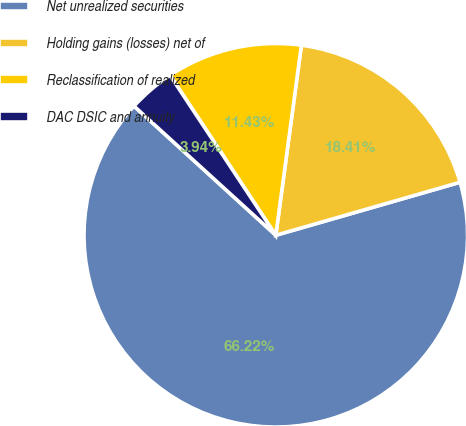<chart> <loc_0><loc_0><loc_500><loc_500><pie_chart><fcel>Net unrealized securities<fcel>Holding gains (losses) net of<fcel>Reclassification of realized<fcel>DAC DSIC and annuity<nl><fcel>66.22%<fcel>18.41%<fcel>11.43%<fcel>3.94%<nl></chart> 